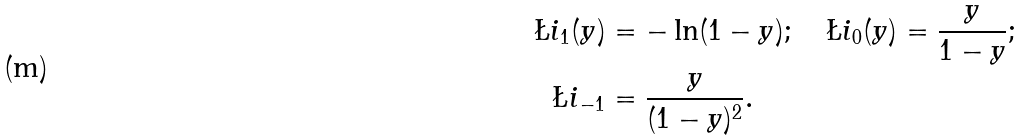Convert formula to latex. <formula><loc_0><loc_0><loc_500><loc_500>\L i _ { 1 } ( y ) & = - \ln ( 1 - y ) ; \quad \L i _ { 0 } ( y ) = \frac { y } { 1 - y } ; \\ \L i _ { - 1 } & = \frac { y } { ( 1 - y ) ^ { 2 } } .</formula> 